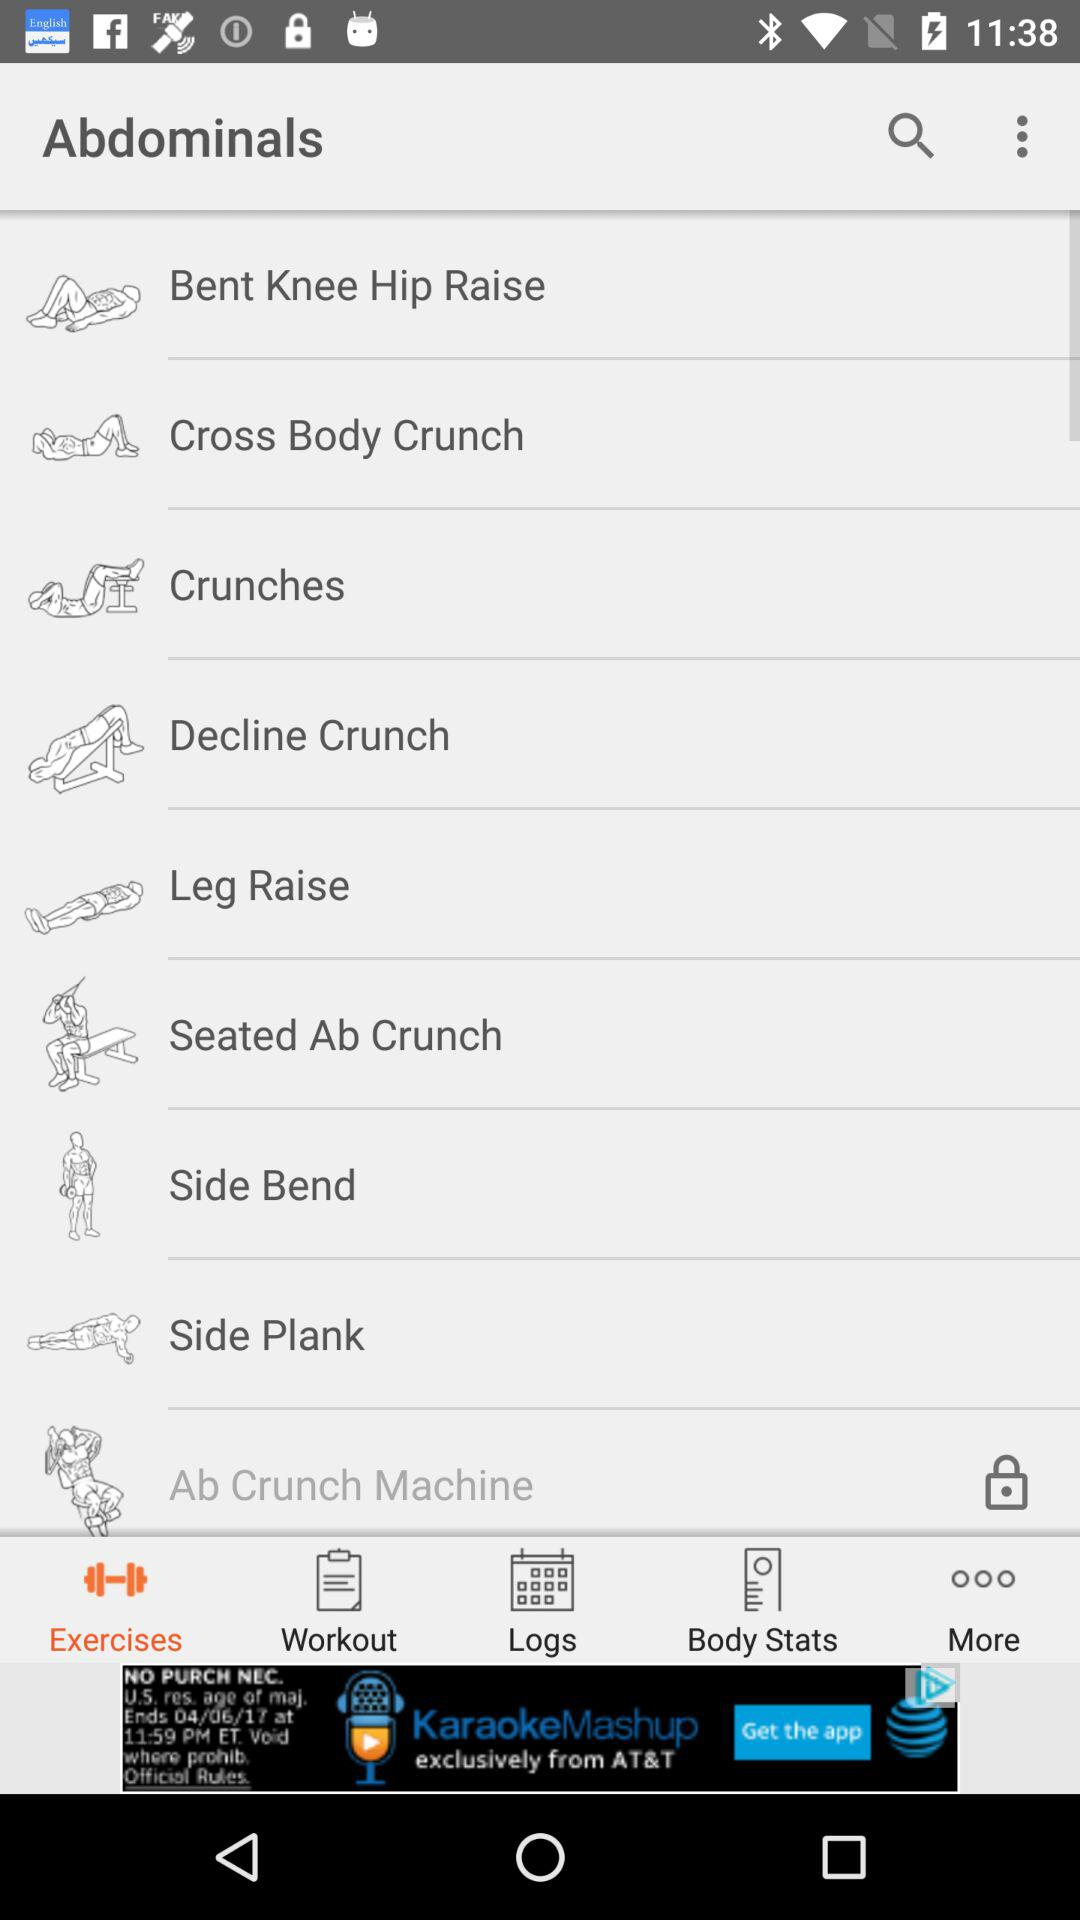How many exercises are in the abdominals section?
Answer the question using a single word or phrase. 9 